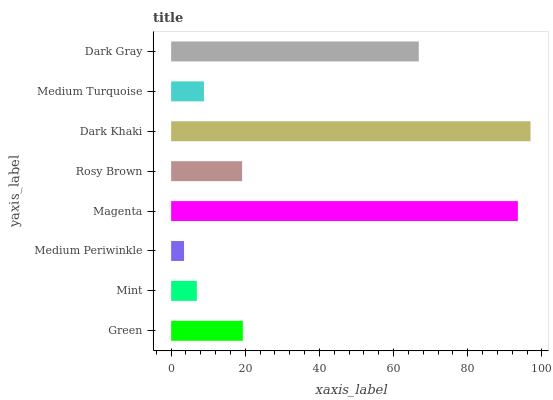Is Medium Periwinkle the minimum?
Answer yes or no. Yes. Is Dark Khaki the maximum?
Answer yes or no. Yes. Is Mint the minimum?
Answer yes or no. No. Is Mint the maximum?
Answer yes or no. No. Is Green greater than Mint?
Answer yes or no. Yes. Is Mint less than Green?
Answer yes or no. Yes. Is Mint greater than Green?
Answer yes or no. No. Is Green less than Mint?
Answer yes or no. No. Is Green the high median?
Answer yes or no. Yes. Is Rosy Brown the low median?
Answer yes or no. Yes. Is Dark Gray the high median?
Answer yes or no. No. Is Green the low median?
Answer yes or no. No. 